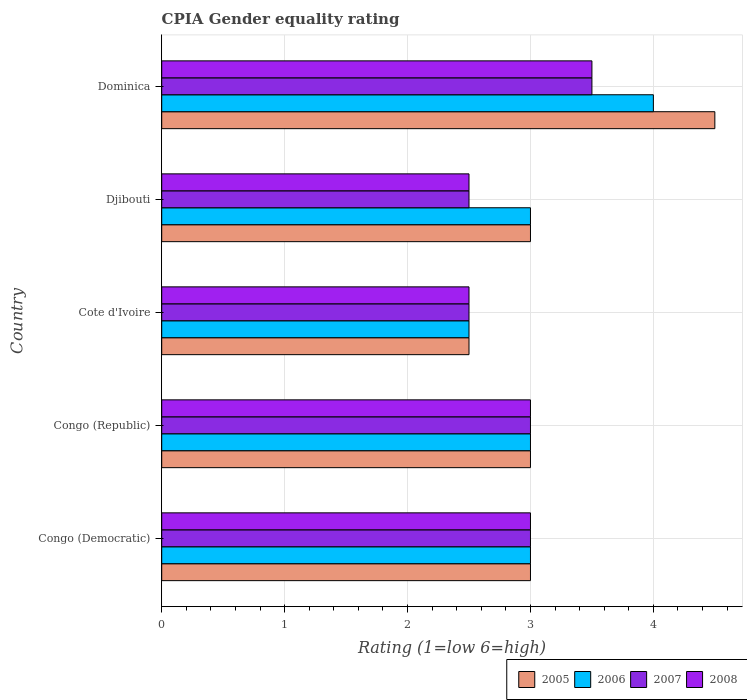Are the number of bars per tick equal to the number of legend labels?
Give a very brief answer. Yes. What is the label of the 5th group of bars from the top?
Provide a short and direct response. Congo (Democratic). What is the CPIA rating in 2008 in Cote d'Ivoire?
Your answer should be very brief. 2.5. In which country was the CPIA rating in 2007 maximum?
Make the answer very short. Dominica. In which country was the CPIA rating in 2005 minimum?
Provide a succinct answer. Cote d'Ivoire. What is the total CPIA rating in 2008 in the graph?
Ensure brevity in your answer.  14.5. What is the difference between the CPIA rating in 2008 and CPIA rating in 2007 in Cote d'Ivoire?
Your answer should be very brief. 0. In how many countries, is the CPIA rating in 2007 greater than 1.2 ?
Your answer should be compact. 5. What is the ratio of the CPIA rating in 2007 in Djibouti to that in Dominica?
Ensure brevity in your answer.  0.71. Is the CPIA rating in 2006 in Congo (Democratic) less than that in Djibouti?
Provide a succinct answer. No. What is the difference between the highest and the second highest CPIA rating in 2008?
Offer a very short reply. 0.5. Is it the case that in every country, the sum of the CPIA rating in 2007 and CPIA rating in 2008 is greater than the sum of CPIA rating in 2005 and CPIA rating in 2006?
Ensure brevity in your answer.  No. What does the 2nd bar from the bottom in Dominica represents?
Your response must be concise. 2006. How many bars are there?
Provide a short and direct response. 20. Are all the bars in the graph horizontal?
Offer a very short reply. Yes. How many countries are there in the graph?
Your response must be concise. 5. Are the values on the major ticks of X-axis written in scientific E-notation?
Give a very brief answer. No. Does the graph contain any zero values?
Provide a succinct answer. No. Where does the legend appear in the graph?
Your answer should be very brief. Bottom right. How are the legend labels stacked?
Provide a short and direct response. Horizontal. What is the title of the graph?
Give a very brief answer. CPIA Gender equality rating. What is the label or title of the X-axis?
Offer a terse response. Rating (1=low 6=high). What is the label or title of the Y-axis?
Keep it short and to the point. Country. What is the Rating (1=low 6=high) in 2006 in Congo (Democratic)?
Your response must be concise. 3. What is the Rating (1=low 6=high) in 2005 in Congo (Republic)?
Offer a very short reply. 3. What is the Rating (1=low 6=high) in 2006 in Congo (Republic)?
Provide a short and direct response. 3. What is the Rating (1=low 6=high) of 2008 in Congo (Republic)?
Make the answer very short. 3. What is the Rating (1=low 6=high) in 2005 in Cote d'Ivoire?
Make the answer very short. 2.5. What is the Rating (1=low 6=high) of 2006 in Cote d'Ivoire?
Your response must be concise. 2.5. What is the Rating (1=low 6=high) of 2008 in Cote d'Ivoire?
Provide a succinct answer. 2.5. What is the Rating (1=low 6=high) of 2006 in Djibouti?
Make the answer very short. 3. What is the Rating (1=low 6=high) in 2007 in Djibouti?
Your answer should be compact. 2.5. What is the Rating (1=low 6=high) in 2005 in Dominica?
Your answer should be very brief. 4.5. What is the Rating (1=low 6=high) in 2007 in Dominica?
Keep it short and to the point. 3.5. Across all countries, what is the maximum Rating (1=low 6=high) in 2006?
Ensure brevity in your answer.  4. Across all countries, what is the minimum Rating (1=low 6=high) in 2005?
Your answer should be very brief. 2.5. Across all countries, what is the minimum Rating (1=low 6=high) of 2006?
Keep it short and to the point. 2.5. Across all countries, what is the minimum Rating (1=low 6=high) in 2007?
Give a very brief answer. 2.5. Across all countries, what is the minimum Rating (1=low 6=high) in 2008?
Provide a short and direct response. 2.5. What is the total Rating (1=low 6=high) of 2006 in the graph?
Offer a very short reply. 15.5. What is the total Rating (1=low 6=high) of 2007 in the graph?
Your answer should be compact. 14.5. What is the difference between the Rating (1=low 6=high) of 2005 in Congo (Democratic) and that in Congo (Republic)?
Provide a short and direct response. 0. What is the difference between the Rating (1=low 6=high) of 2006 in Congo (Democratic) and that in Congo (Republic)?
Offer a very short reply. 0. What is the difference between the Rating (1=low 6=high) in 2007 in Congo (Democratic) and that in Congo (Republic)?
Make the answer very short. 0. What is the difference between the Rating (1=low 6=high) in 2008 in Congo (Democratic) and that in Congo (Republic)?
Offer a terse response. 0. What is the difference between the Rating (1=low 6=high) in 2006 in Congo (Democratic) and that in Cote d'Ivoire?
Provide a short and direct response. 0.5. What is the difference between the Rating (1=low 6=high) in 2007 in Congo (Democratic) and that in Cote d'Ivoire?
Ensure brevity in your answer.  0.5. What is the difference between the Rating (1=low 6=high) of 2008 in Congo (Democratic) and that in Cote d'Ivoire?
Ensure brevity in your answer.  0.5. What is the difference between the Rating (1=low 6=high) in 2006 in Congo (Republic) and that in Cote d'Ivoire?
Provide a succinct answer. 0.5. What is the difference between the Rating (1=low 6=high) in 2005 in Congo (Republic) and that in Djibouti?
Keep it short and to the point. 0. What is the difference between the Rating (1=low 6=high) of 2008 in Congo (Republic) and that in Dominica?
Your answer should be very brief. -0.5. What is the difference between the Rating (1=low 6=high) of 2008 in Cote d'Ivoire and that in Djibouti?
Make the answer very short. 0. What is the difference between the Rating (1=low 6=high) in 2005 in Cote d'Ivoire and that in Dominica?
Your response must be concise. -2. What is the difference between the Rating (1=low 6=high) in 2006 in Cote d'Ivoire and that in Dominica?
Offer a terse response. -1.5. What is the difference between the Rating (1=low 6=high) of 2007 in Cote d'Ivoire and that in Dominica?
Make the answer very short. -1. What is the difference between the Rating (1=low 6=high) of 2008 in Cote d'Ivoire and that in Dominica?
Give a very brief answer. -1. What is the difference between the Rating (1=low 6=high) in 2007 in Djibouti and that in Dominica?
Give a very brief answer. -1. What is the difference between the Rating (1=low 6=high) in 2008 in Djibouti and that in Dominica?
Your answer should be compact. -1. What is the difference between the Rating (1=low 6=high) of 2005 in Congo (Democratic) and the Rating (1=low 6=high) of 2006 in Congo (Republic)?
Your answer should be very brief. 0. What is the difference between the Rating (1=low 6=high) in 2006 in Congo (Democratic) and the Rating (1=low 6=high) in 2008 in Congo (Republic)?
Your answer should be very brief. 0. What is the difference between the Rating (1=low 6=high) in 2005 in Congo (Democratic) and the Rating (1=low 6=high) in 2006 in Cote d'Ivoire?
Keep it short and to the point. 0.5. What is the difference between the Rating (1=low 6=high) of 2006 in Congo (Democratic) and the Rating (1=low 6=high) of 2008 in Cote d'Ivoire?
Ensure brevity in your answer.  0.5. What is the difference between the Rating (1=low 6=high) in 2007 in Congo (Democratic) and the Rating (1=low 6=high) in 2008 in Cote d'Ivoire?
Provide a succinct answer. 0.5. What is the difference between the Rating (1=low 6=high) of 2005 in Congo (Democratic) and the Rating (1=low 6=high) of 2006 in Djibouti?
Keep it short and to the point. 0. What is the difference between the Rating (1=low 6=high) of 2005 in Congo (Democratic) and the Rating (1=low 6=high) of 2007 in Djibouti?
Offer a terse response. 0.5. What is the difference between the Rating (1=low 6=high) of 2005 in Congo (Democratic) and the Rating (1=low 6=high) of 2008 in Djibouti?
Provide a short and direct response. 0.5. What is the difference between the Rating (1=low 6=high) in 2006 in Congo (Democratic) and the Rating (1=low 6=high) in 2007 in Djibouti?
Your response must be concise. 0.5. What is the difference between the Rating (1=low 6=high) of 2006 in Congo (Democratic) and the Rating (1=low 6=high) of 2008 in Djibouti?
Your answer should be compact. 0.5. What is the difference between the Rating (1=low 6=high) of 2007 in Congo (Democratic) and the Rating (1=low 6=high) of 2008 in Djibouti?
Offer a terse response. 0.5. What is the difference between the Rating (1=low 6=high) in 2005 in Congo (Democratic) and the Rating (1=low 6=high) in 2006 in Dominica?
Keep it short and to the point. -1. What is the difference between the Rating (1=low 6=high) of 2006 in Congo (Democratic) and the Rating (1=low 6=high) of 2007 in Dominica?
Provide a succinct answer. -0.5. What is the difference between the Rating (1=low 6=high) of 2006 in Congo (Democratic) and the Rating (1=low 6=high) of 2008 in Dominica?
Give a very brief answer. -0.5. What is the difference between the Rating (1=low 6=high) of 2006 in Congo (Republic) and the Rating (1=low 6=high) of 2007 in Cote d'Ivoire?
Your answer should be compact. 0.5. What is the difference between the Rating (1=low 6=high) in 2005 in Congo (Republic) and the Rating (1=low 6=high) in 2007 in Djibouti?
Your answer should be compact. 0.5. What is the difference between the Rating (1=low 6=high) in 2006 in Congo (Republic) and the Rating (1=low 6=high) in 2007 in Djibouti?
Your answer should be compact. 0.5. What is the difference between the Rating (1=low 6=high) of 2006 in Congo (Republic) and the Rating (1=low 6=high) of 2008 in Djibouti?
Your answer should be very brief. 0.5. What is the difference between the Rating (1=low 6=high) of 2007 in Congo (Republic) and the Rating (1=low 6=high) of 2008 in Djibouti?
Provide a succinct answer. 0.5. What is the difference between the Rating (1=low 6=high) of 2005 in Congo (Republic) and the Rating (1=low 6=high) of 2006 in Dominica?
Your response must be concise. -1. What is the difference between the Rating (1=low 6=high) in 2005 in Cote d'Ivoire and the Rating (1=low 6=high) in 2007 in Djibouti?
Your response must be concise. 0. What is the difference between the Rating (1=low 6=high) in 2005 in Cote d'Ivoire and the Rating (1=low 6=high) in 2008 in Djibouti?
Your answer should be very brief. 0. What is the difference between the Rating (1=low 6=high) in 2006 in Cote d'Ivoire and the Rating (1=low 6=high) in 2008 in Djibouti?
Make the answer very short. 0. What is the difference between the Rating (1=low 6=high) in 2007 in Cote d'Ivoire and the Rating (1=low 6=high) in 2008 in Djibouti?
Your response must be concise. 0. What is the difference between the Rating (1=low 6=high) in 2005 in Cote d'Ivoire and the Rating (1=low 6=high) in 2006 in Dominica?
Provide a succinct answer. -1.5. What is the difference between the Rating (1=low 6=high) of 2005 in Cote d'Ivoire and the Rating (1=low 6=high) of 2007 in Dominica?
Your answer should be very brief. -1. What is the difference between the Rating (1=low 6=high) in 2007 in Cote d'Ivoire and the Rating (1=low 6=high) in 2008 in Dominica?
Offer a terse response. -1. What is the difference between the Rating (1=low 6=high) of 2005 in Djibouti and the Rating (1=low 6=high) of 2006 in Dominica?
Offer a terse response. -1. What is the difference between the Rating (1=low 6=high) in 2005 in Djibouti and the Rating (1=low 6=high) in 2008 in Dominica?
Make the answer very short. -0.5. What is the difference between the Rating (1=low 6=high) in 2006 in Djibouti and the Rating (1=low 6=high) in 2008 in Dominica?
Your response must be concise. -0.5. What is the difference between the Rating (1=low 6=high) of 2007 in Djibouti and the Rating (1=low 6=high) of 2008 in Dominica?
Your response must be concise. -1. What is the average Rating (1=low 6=high) in 2005 per country?
Offer a very short reply. 3.2. What is the average Rating (1=low 6=high) in 2006 per country?
Your answer should be very brief. 3.1. What is the average Rating (1=low 6=high) in 2007 per country?
Provide a succinct answer. 2.9. What is the average Rating (1=low 6=high) in 2008 per country?
Give a very brief answer. 2.9. What is the difference between the Rating (1=low 6=high) in 2005 and Rating (1=low 6=high) in 2007 in Congo (Democratic)?
Your answer should be compact. 0. What is the difference between the Rating (1=low 6=high) in 2005 and Rating (1=low 6=high) in 2006 in Congo (Republic)?
Offer a terse response. 0. What is the difference between the Rating (1=low 6=high) of 2005 and Rating (1=low 6=high) of 2007 in Congo (Republic)?
Offer a terse response. 0. What is the difference between the Rating (1=low 6=high) in 2005 and Rating (1=low 6=high) in 2008 in Congo (Republic)?
Your answer should be very brief. 0. What is the difference between the Rating (1=low 6=high) in 2006 and Rating (1=low 6=high) in 2007 in Congo (Republic)?
Provide a succinct answer. 0. What is the difference between the Rating (1=low 6=high) in 2006 and Rating (1=low 6=high) in 2008 in Congo (Republic)?
Give a very brief answer. 0. What is the difference between the Rating (1=low 6=high) of 2005 and Rating (1=low 6=high) of 2006 in Cote d'Ivoire?
Offer a terse response. 0. What is the difference between the Rating (1=low 6=high) in 2005 and Rating (1=low 6=high) in 2007 in Cote d'Ivoire?
Offer a very short reply. 0. What is the difference between the Rating (1=low 6=high) of 2006 and Rating (1=low 6=high) of 2007 in Cote d'Ivoire?
Make the answer very short. 0. What is the difference between the Rating (1=low 6=high) in 2006 and Rating (1=low 6=high) in 2008 in Cote d'Ivoire?
Provide a short and direct response. 0. What is the difference between the Rating (1=low 6=high) in 2005 and Rating (1=low 6=high) in 2006 in Djibouti?
Your answer should be very brief. 0. What is the difference between the Rating (1=low 6=high) of 2005 and Rating (1=low 6=high) of 2007 in Djibouti?
Provide a short and direct response. 0.5. What is the difference between the Rating (1=low 6=high) of 2005 and Rating (1=low 6=high) of 2008 in Djibouti?
Offer a very short reply. 0.5. What is the difference between the Rating (1=low 6=high) of 2006 and Rating (1=low 6=high) of 2008 in Djibouti?
Provide a short and direct response. 0.5. What is the difference between the Rating (1=low 6=high) of 2005 and Rating (1=low 6=high) of 2006 in Dominica?
Give a very brief answer. 0.5. What is the difference between the Rating (1=low 6=high) in 2005 and Rating (1=low 6=high) in 2007 in Dominica?
Offer a terse response. 1. What is the difference between the Rating (1=low 6=high) of 2005 and Rating (1=low 6=high) of 2008 in Dominica?
Ensure brevity in your answer.  1. What is the difference between the Rating (1=low 6=high) in 2006 and Rating (1=low 6=high) in 2007 in Dominica?
Keep it short and to the point. 0.5. What is the ratio of the Rating (1=low 6=high) in 2006 in Congo (Democratic) to that in Congo (Republic)?
Make the answer very short. 1. What is the ratio of the Rating (1=low 6=high) in 2007 in Congo (Democratic) to that in Congo (Republic)?
Offer a very short reply. 1. What is the ratio of the Rating (1=low 6=high) in 2005 in Congo (Democratic) to that in Cote d'Ivoire?
Make the answer very short. 1.2. What is the ratio of the Rating (1=low 6=high) in 2008 in Congo (Democratic) to that in Cote d'Ivoire?
Provide a succinct answer. 1.2. What is the ratio of the Rating (1=low 6=high) of 2007 in Congo (Democratic) to that in Djibouti?
Your answer should be very brief. 1.2. What is the ratio of the Rating (1=low 6=high) in 2005 in Congo (Democratic) to that in Dominica?
Keep it short and to the point. 0.67. What is the ratio of the Rating (1=low 6=high) of 2007 in Congo (Democratic) to that in Dominica?
Keep it short and to the point. 0.86. What is the ratio of the Rating (1=low 6=high) of 2008 in Congo (Democratic) to that in Dominica?
Give a very brief answer. 0.86. What is the ratio of the Rating (1=low 6=high) in 2006 in Congo (Republic) to that in Cote d'Ivoire?
Offer a terse response. 1.2. What is the ratio of the Rating (1=low 6=high) of 2007 in Congo (Republic) to that in Cote d'Ivoire?
Your answer should be very brief. 1.2. What is the ratio of the Rating (1=low 6=high) of 2005 in Congo (Republic) to that in Djibouti?
Provide a succinct answer. 1. What is the ratio of the Rating (1=low 6=high) of 2006 in Congo (Republic) to that in Djibouti?
Your answer should be very brief. 1. What is the ratio of the Rating (1=low 6=high) of 2007 in Congo (Republic) to that in Djibouti?
Offer a very short reply. 1.2. What is the ratio of the Rating (1=low 6=high) in 2008 in Congo (Republic) to that in Djibouti?
Ensure brevity in your answer.  1.2. What is the ratio of the Rating (1=low 6=high) of 2008 in Congo (Republic) to that in Dominica?
Your response must be concise. 0.86. What is the ratio of the Rating (1=low 6=high) of 2005 in Cote d'Ivoire to that in Dominica?
Your answer should be very brief. 0.56. What is the ratio of the Rating (1=low 6=high) in 2006 in Cote d'Ivoire to that in Dominica?
Provide a succinct answer. 0.62. What is the ratio of the Rating (1=low 6=high) of 2005 in Djibouti to that in Dominica?
Offer a very short reply. 0.67. What is the difference between the highest and the lowest Rating (1=low 6=high) in 2005?
Provide a succinct answer. 2. What is the difference between the highest and the lowest Rating (1=low 6=high) of 2007?
Your answer should be compact. 1. 